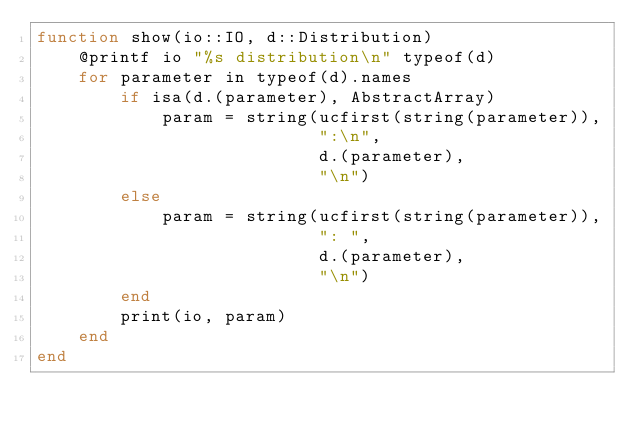Convert code to text. <code><loc_0><loc_0><loc_500><loc_500><_Julia_>function show(io::IO, d::Distribution)
    @printf io "%s distribution\n" typeof(d)
    for parameter in typeof(d).names
        if isa(d.(parameter), AbstractArray)
            param = string(ucfirst(string(parameter)),
                           ":\n",
                           d.(parameter),
                           "\n")
        else
            param = string(ucfirst(string(parameter)),
                           ": ",
                           d.(parameter),
                           "\n")
        end
        print(io, param)
    end
end
</code> 